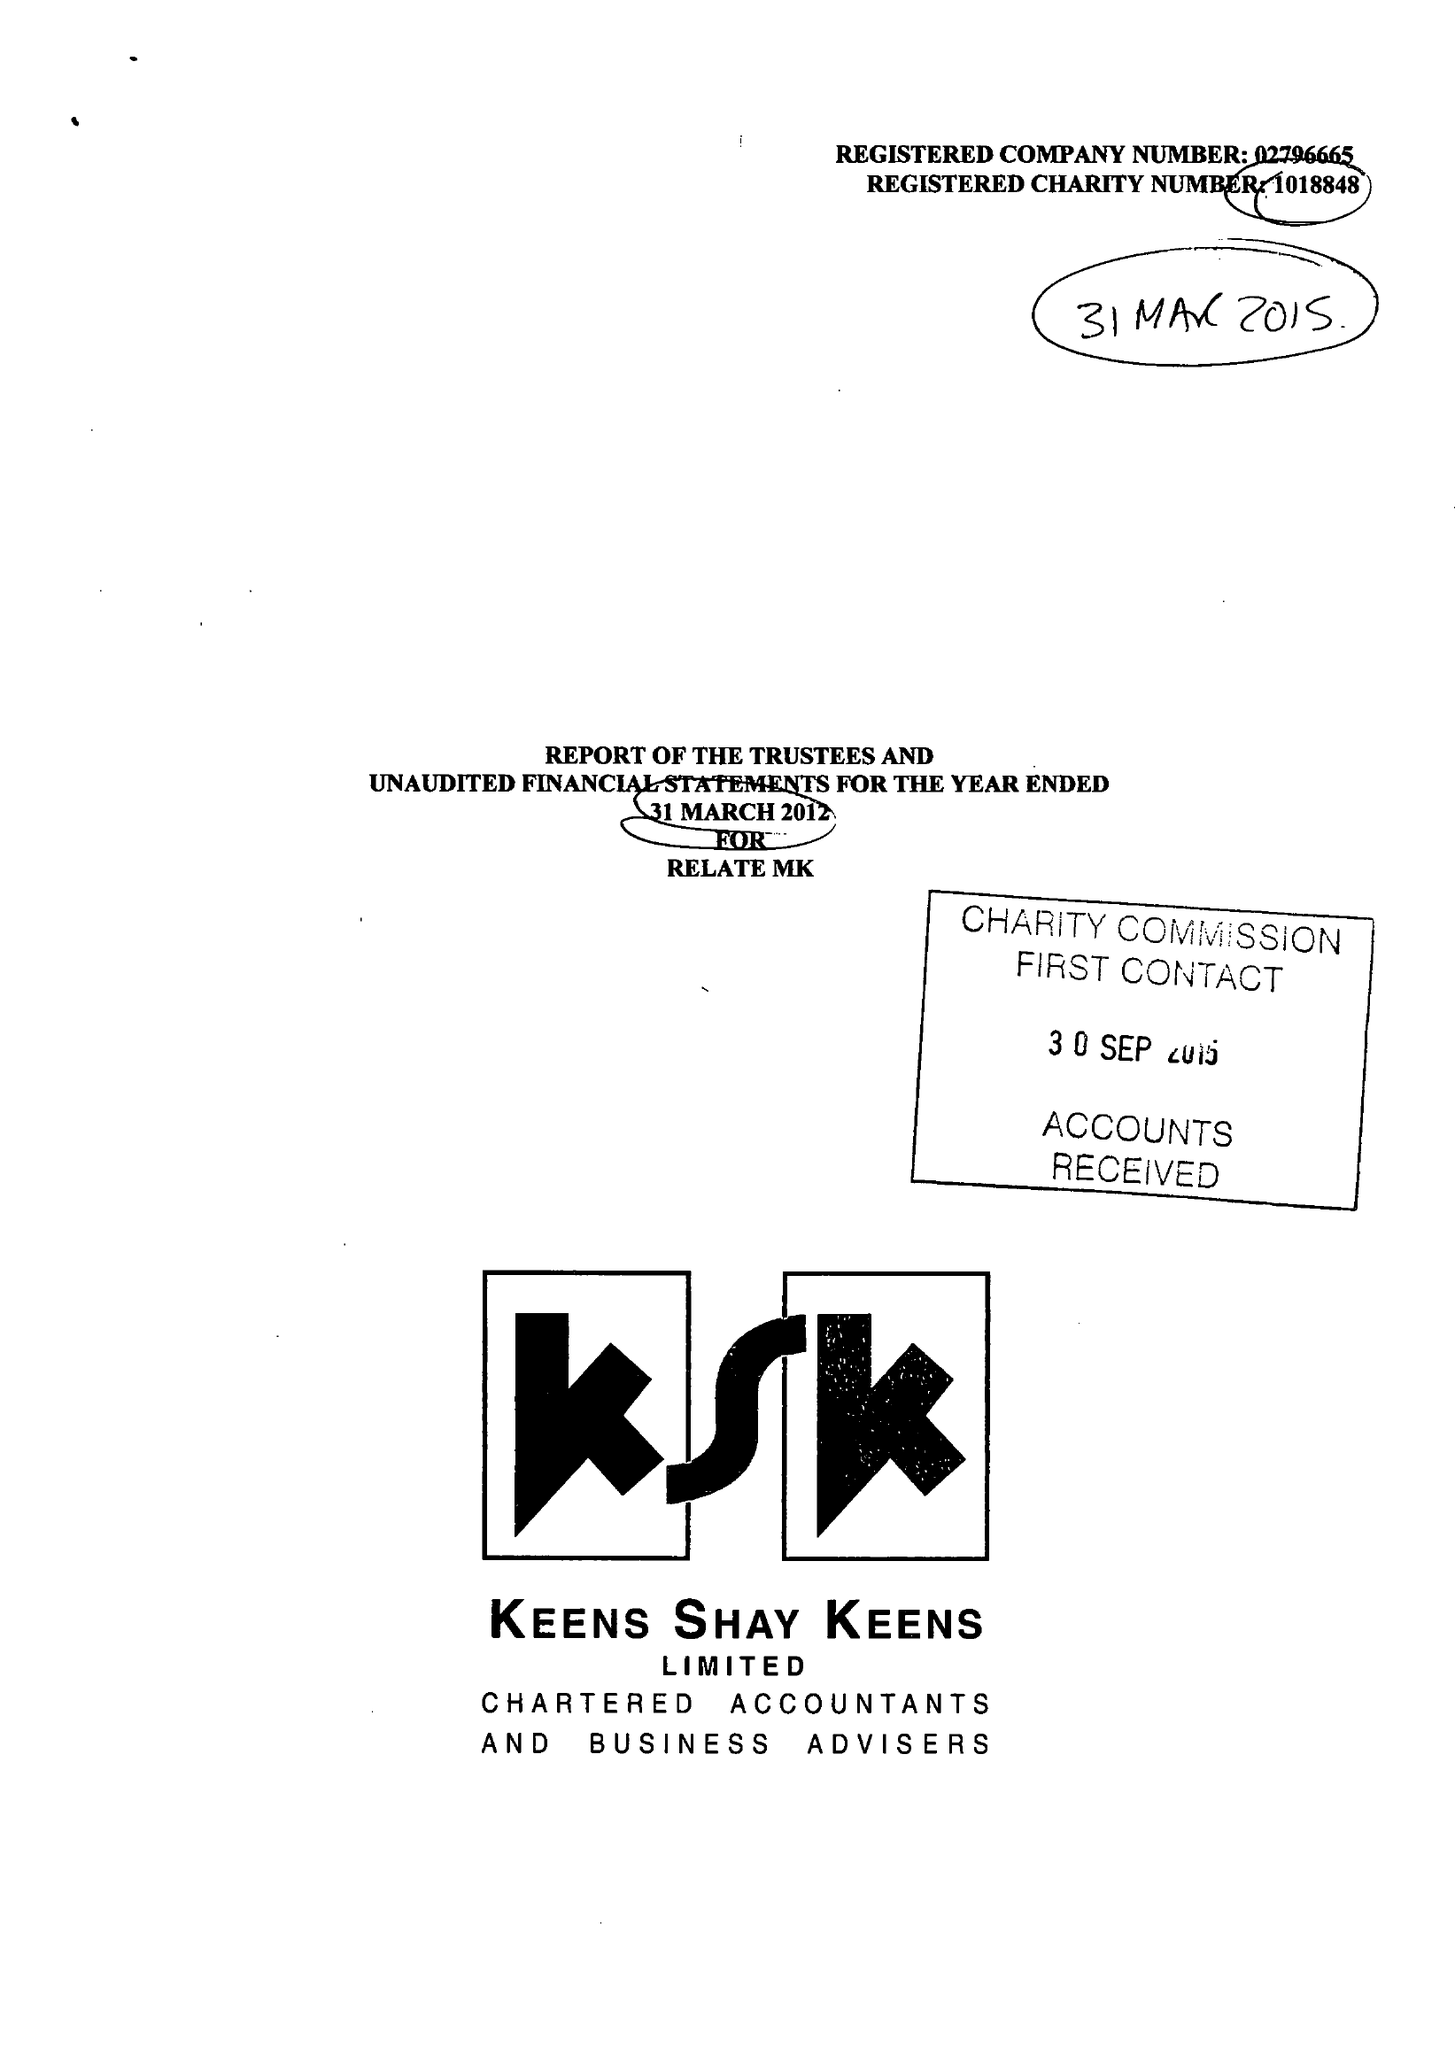What is the value for the address__postcode?
Answer the question using a single word or phrase. MK12 5HX 